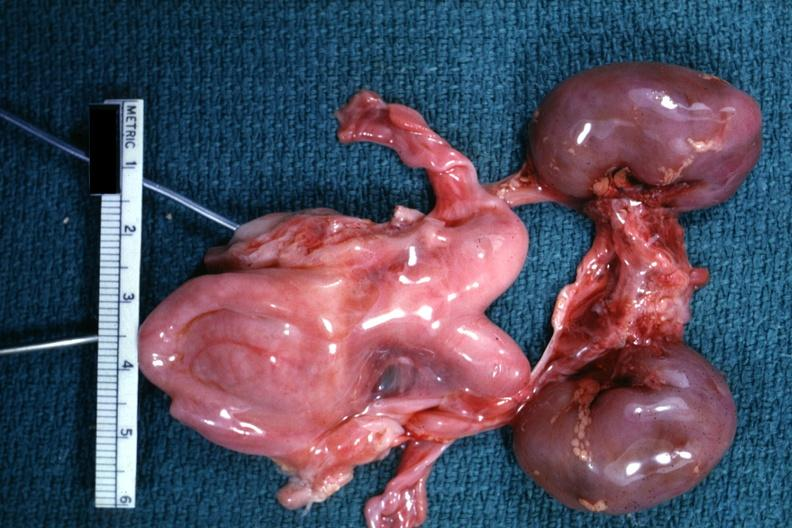does beckwith-wiedemann syndrome show infant organs clearly shown lesion?
Answer the question using a single word or phrase. No 